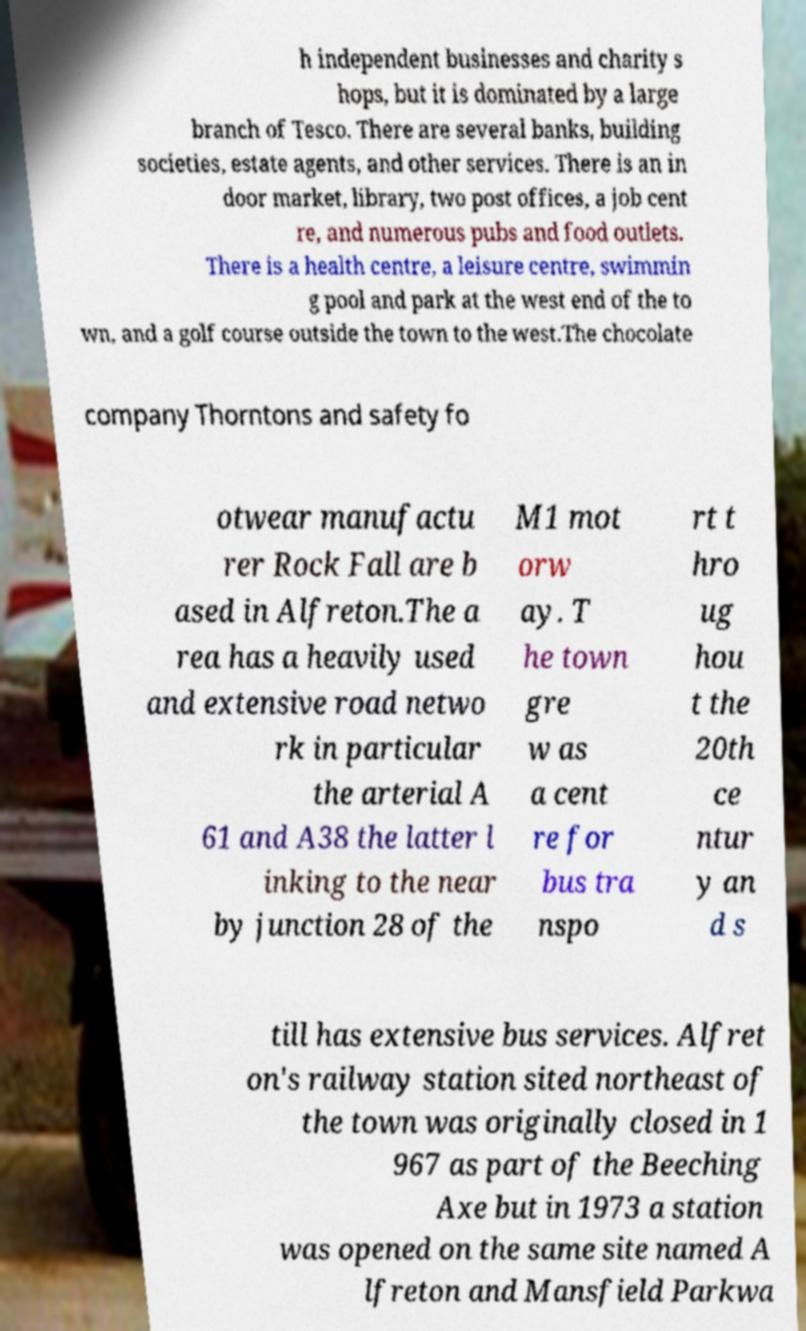Could you assist in decoding the text presented in this image and type it out clearly? h independent businesses and charity s hops, but it is dominated by a large branch of Tesco. There are several banks, building societies, estate agents, and other services. There is an in door market, library, two post offices, a job cent re, and numerous pubs and food outlets. There is a health centre, a leisure centre, swimmin g pool and park at the west end of the to wn, and a golf course outside the town to the west.The chocolate company Thorntons and safety fo otwear manufactu rer Rock Fall are b ased in Alfreton.The a rea has a heavily used and extensive road netwo rk in particular the arterial A 61 and A38 the latter l inking to the near by junction 28 of the M1 mot orw ay. T he town gre w as a cent re for bus tra nspo rt t hro ug hou t the 20th ce ntur y an d s till has extensive bus services. Alfret on's railway station sited northeast of the town was originally closed in 1 967 as part of the Beeching Axe but in 1973 a station was opened on the same site named A lfreton and Mansfield Parkwa 